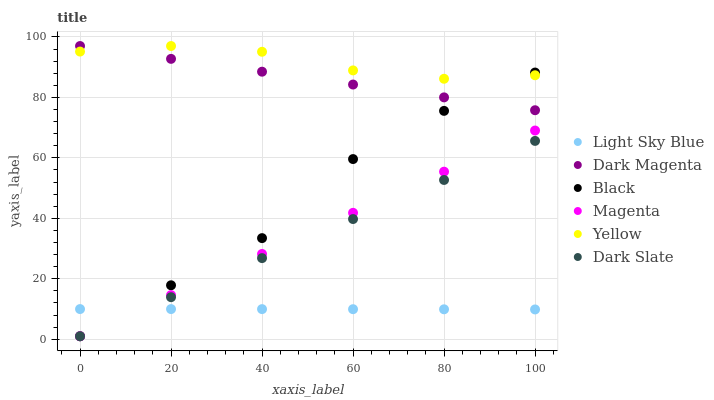Does Light Sky Blue have the minimum area under the curve?
Answer yes or no. Yes. Does Yellow have the maximum area under the curve?
Answer yes or no. Yes. Does Dark Slate have the minimum area under the curve?
Answer yes or no. No. Does Dark Slate have the maximum area under the curve?
Answer yes or no. No. Is Dark Magenta the smoothest?
Answer yes or no. Yes. Is Black the roughest?
Answer yes or no. Yes. Is Yellow the smoothest?
Answer yes or no. No. Is Yellow the roughest?
Answer yes or no. No. Does Dark Slate have the lowest value?
Answer yes or no. Yes. Does Yellow have the lowest value?
Answer yes or no. No. Does Yellow have the highest value?
Answer yes or no. Yes. Does Dark Slate have the highest value?
Answer yes or no. No. Is Magenta less than Dark Magenta?
Answer yes or no. Yes. Is Yellow greater than Dark Slate?
Answer yes or no. Yes. Does Light Sky Blue intersect Dark Slate?
Answer yes or no. Yes. Is Light Sky Blue less than Dark Slate?
Answer yes or no. No. Is Light Sky Blue greater than Dark Slate?
Answer yes or no. No. Does Magenta intersect Dark Magenta?
Answer yes or no. No. 